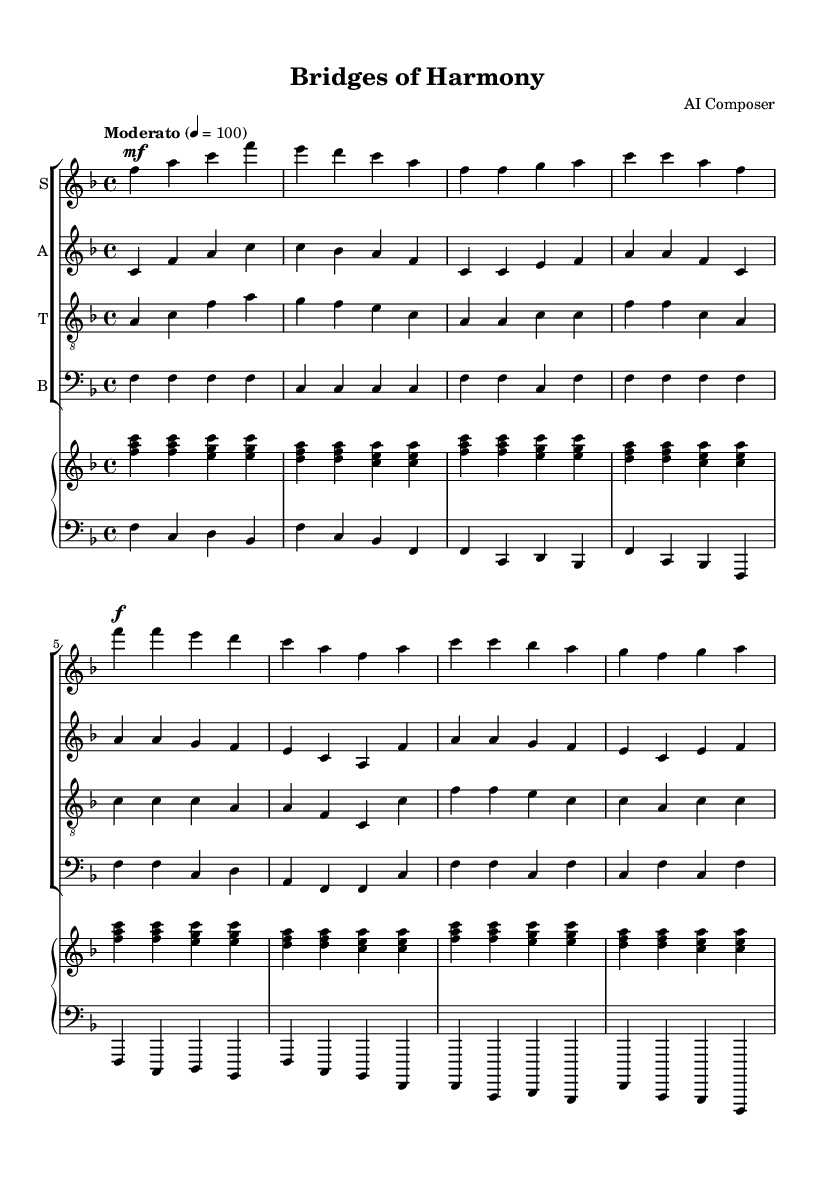What is the key signature of this music? The key signature is F major, indicated by one flat (B flat). This is determined from the first part of the music sheet shown in the key signature section, where the symbol for B flat is present.
Answer: F major What is the time signature of this music? The time signature is 4/4, indicated right after the key signature in the musical notation. It informs musicians that there are four beats in each measure and a quarter note gets one beat.
Answer: 4/4 What is the tempo marking of this piece? The tempo marking is "Moderato" at a speed of 100 beats per minute, indicated at the start of the score. It suggests a moderate pace for the piece.
Answer: Moderato How many parts are there in the choral arrangement? There are four parts in the choral arrangement: Soprano, Alto, Tenor, and Bass. This is deduced from the staff labels at the beginning of each voice line in the score.
Answer: Four What is the primary theme of the lyrics in this piece? The primary theme of the lyrics revolves around cultural unity and togetherness. This can be interpreted from the lines in the lyrics that discuss standing hand in hand and communicating across distant shores.
Answer: Cultural unity How is the musical texture characterized in this piece? The musical texture can be characterized as homophonic, as all voices sing together in harmony, creating a unified sound, with the soprano typically carrying the melody supported by the other voices harmonizing.
Answer: Homophonic What mood does the piece convey through its musical elements? The piece conveys an uplifting mood, as seen through the major key, moderato tempo, and harmonious choral writing, all of which create a sense of joy and celebration regarding the theme of global connectivity.
Answer: Uplifting 